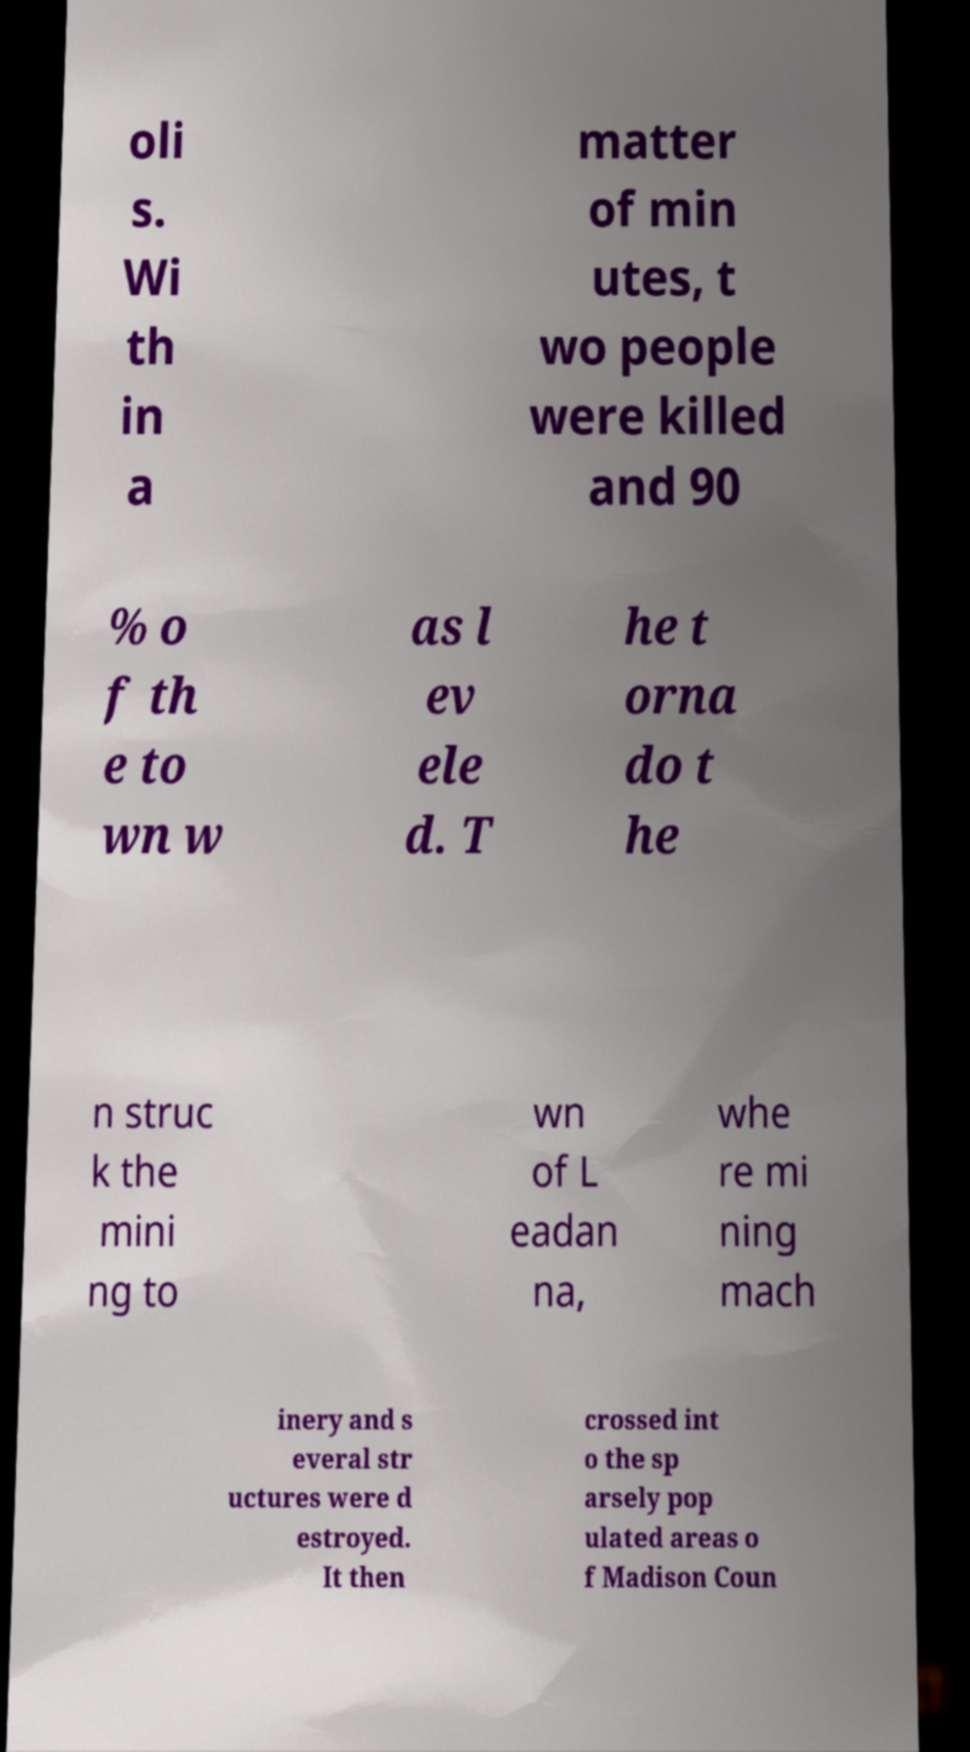What messages or text are displayed in this image? I need them in a readable, typed format. oli s. Wi th in a matter of min utes, t wo people were killed and 90 % o f th e to wn w as l ev ele d. T he t orna do t he n struc k the mini ng to wn of L eadan na, whe re mi ning mach inery and s everal str uctures were d estroyed. It then crossed int o the sp arsely pop ulated areas o f Madison Coun 